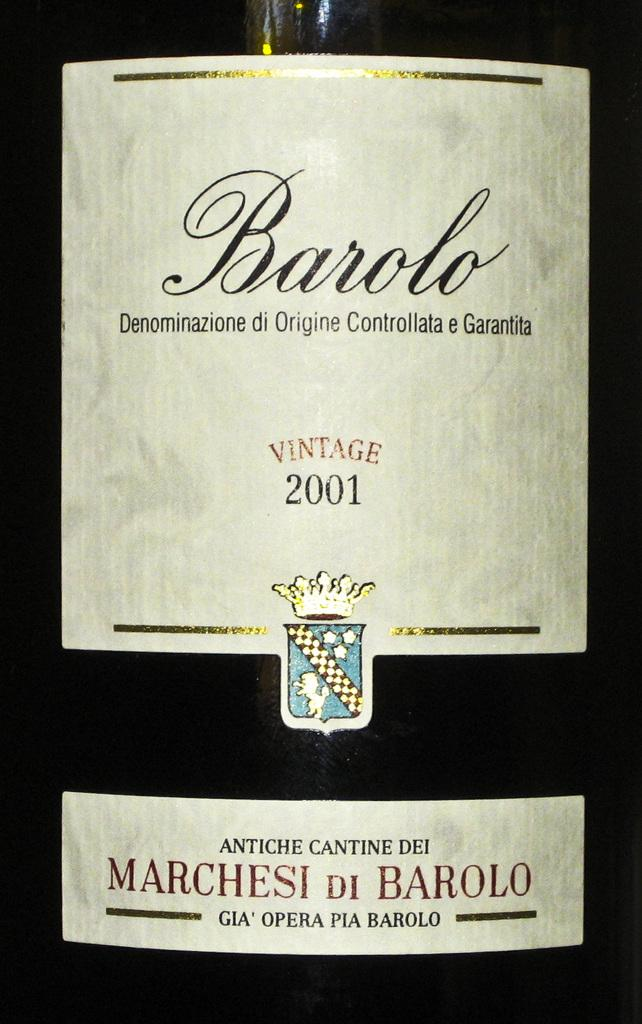<image>
Present a compact description of the photo's key features. a bottle that is from the year 2001 